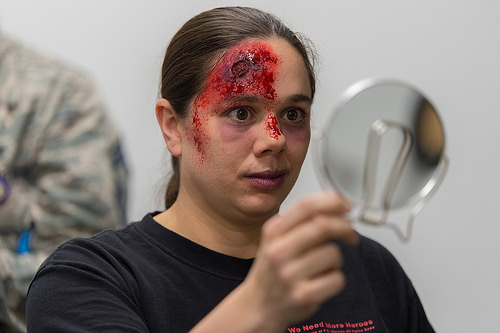<image>
Is there a woman in front of the mirror? Yes. The woman is positioned in front of the mirror, appearing closer to the camera viewpoint. 